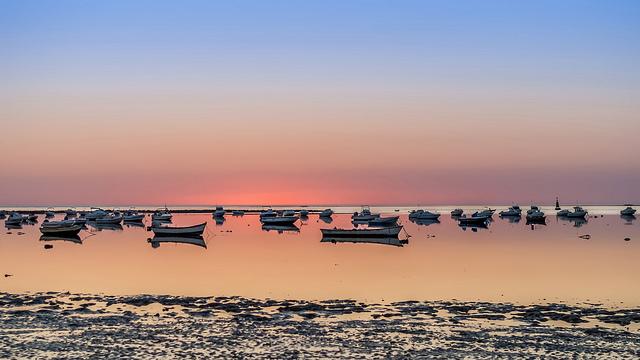What colors appear in the sky in this picture?
Write a very short answer. Blue purple and orange. How many sailboats are in the picture?
Give a very brief answer. 1. What type of seafood are these boats designed to catch?
Keep it brief. Fish. 